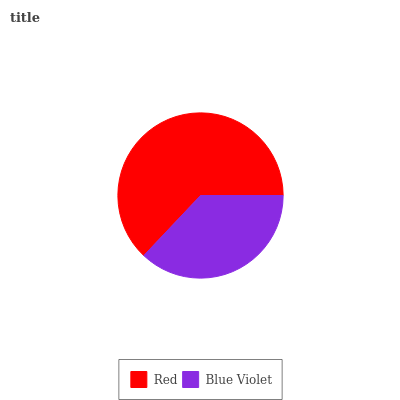Is Blue Violet the minimum?
Answer yes or no. Yes. Is Red the maximum?
Answer yes or no. Yes. Is Blue Violet the maximum?
Answer yes or no. No. Is Red greater than Blue Violet?
Answer yes or no. Yes. Is Blue Violet less than Red?
Answer yes or no. Yes. Is Blue Violet greater than Red?
Answer yes or no. No. Is Red less than Blue Violet?
Answer yes or no. No. Is Red the high median?
Answer yes or no. Yes. Is Blue Violet the low median?
Answer yes or no. Yes. Is Blue Violet the high median?
Answer yes or no. No. Is Red the low median?
Answer yes or no. No. 